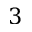<formula> <loc_0><loc_0><loc_500><loc_500>3</formula> 